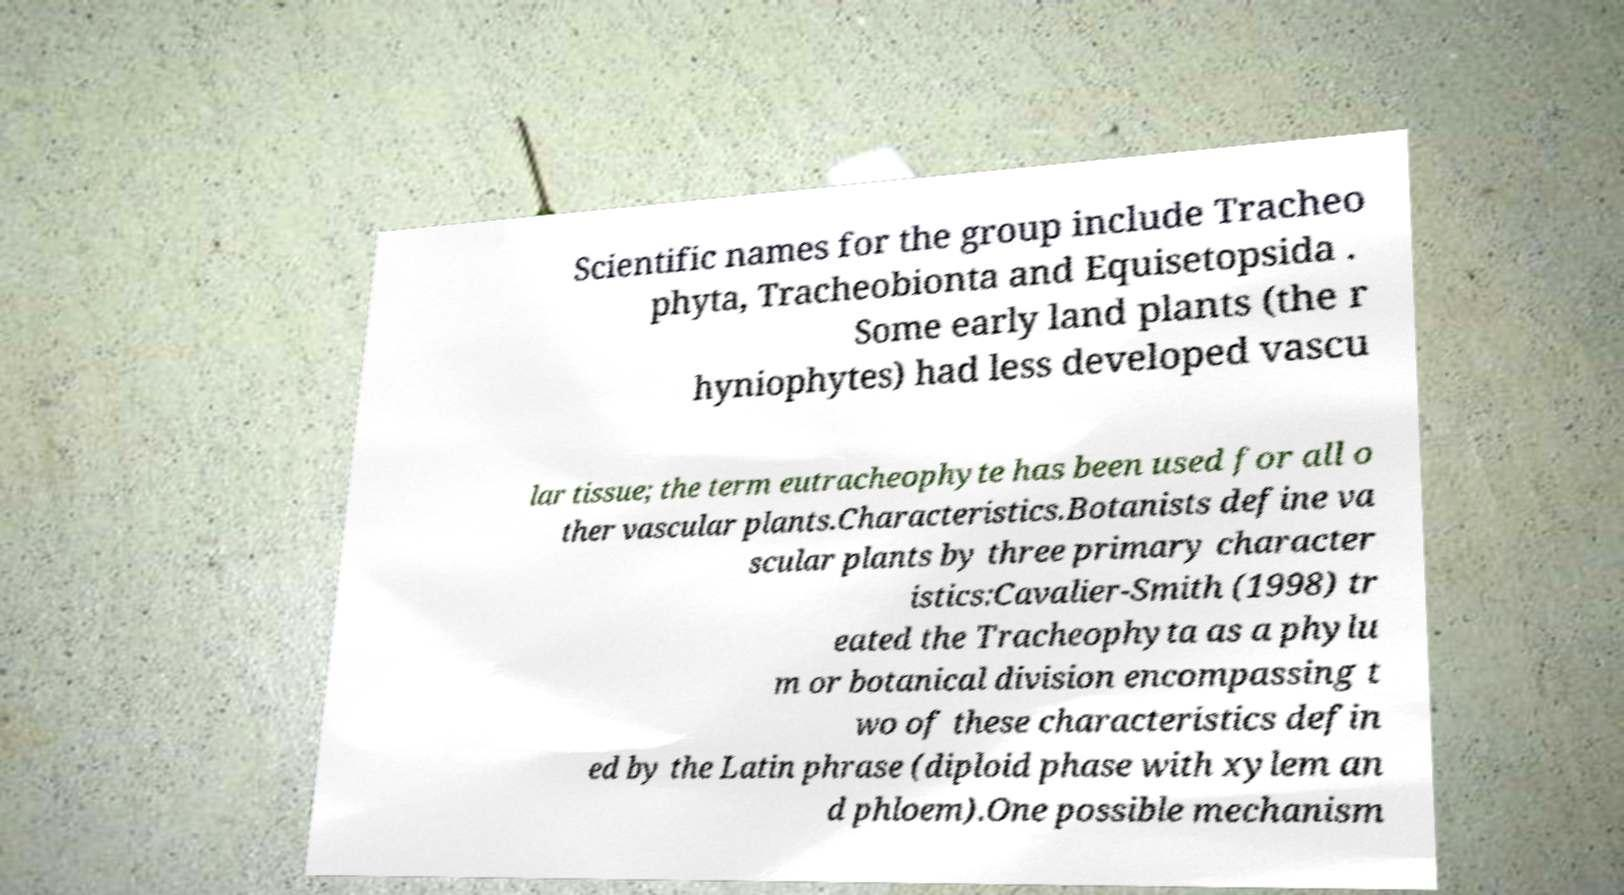I need the written content from this picture converted into text. Can you do that? Scientific names for the group include Tracheo phyta, Tracheobionta and Equisetopsida . Some early land plants (the r hyniophytes) had less developed vascu lar tissue; the term eutracheophyte has been used for all o ther vascular plants.Characteristics.Botanists define va scular plants by three primary character istics:Cavalier-Smith (1998) tr eated the Tracheophyta as a phylu m or botanical division encompassing t wo of these characteristics defin ed by the Latin phrase (diploid phase with xylem an d phloem).One possible mechanism 